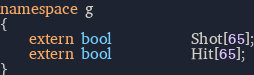<code> <loc_0><loc_0><loc_500><loc_500><_C++_>namespace g
{
    extern bool           Shot[65];
    extern bool           Hit[65];
}
</code> 